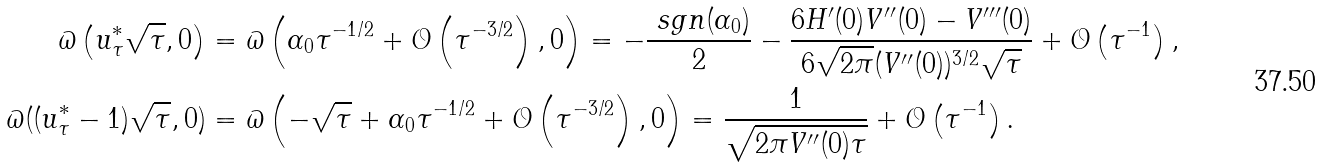Convert formula to latex. <formula><loc_0><loc_0><loc_500><loc_500>\varpi \left ( u ^ { * } _ { \tau } \sqrt { \tau } , 0 \right ) & = \varpi \left ( \alpha _ { 0 } \tau ^ { - 1 / 2 } + \mathcal { O } \left ( \tau ^ { - 3 / 2 } \right ) , 0 \right ) = - \frac { \ s g n ( \alpha _ { 0 } ) } { 2 } - \frac { 6 H ^ { \prime } ( 0 ) V ^ { \prime \prime } ( 0 ) - V ^ { \prime \prime \prime } ( 0 ) } { 6 \sqrt { 2 \pi } ( V ^ { \prime \prime } ( 0 ) ) ^ { 3 / 2 } \sqrt { \tau } } + \mathcal { O } \left ( \tau ^ { - 1 } \right ) , \\ \varpi ( ( u ^ { * } _ { \tau } - 1 ) \sqrt { \tau } , 0 ) & = \varpi \left ( - \sqrt { \tau } + \alpha _ { 0 } \tau ^ { - 1 / 2 } + \mathcal { O } \left ( \tau ^ { - 3 / 2 } \right ) , 0 \right ) = \frac { 1 } { \sqrt { 2 \pi V ^ { \prime \prime } ( 0 ) \tau } } + \mathcal { O } \left ( \tau ^ { - 1 } \right ) .</formula> 